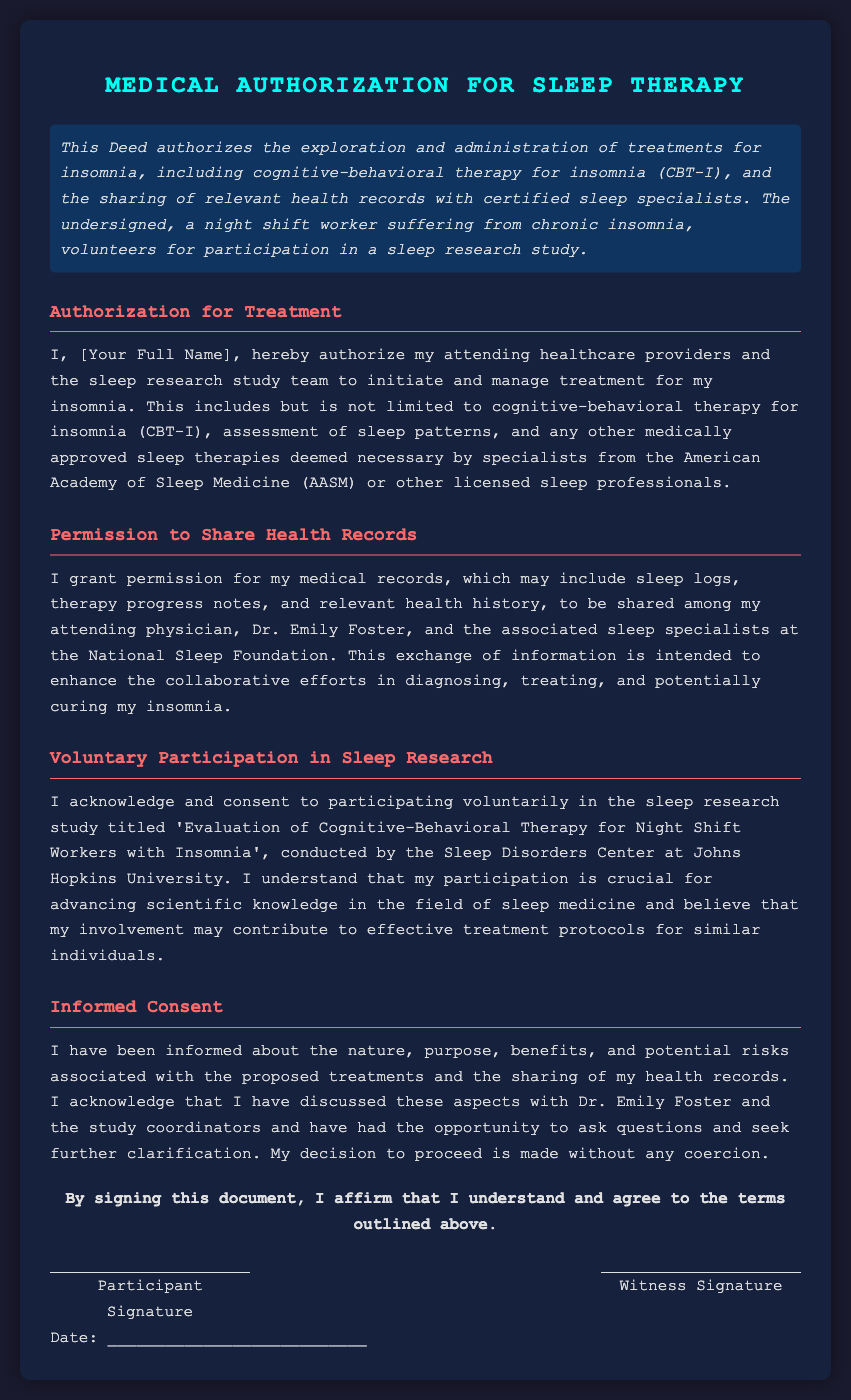What is the title of the document? The title is clearly stated at the top of the document, which indicates its purpose.
Answer: Medical Authorization for Sleep Therapy Who is the attending physician mentioned in the document? The physician's name is specifically written in the section that discusses sharing health records.
Answer: Dr. Emily Foster What type of therapy is primarily mentioned for treating insomnia? The document outlines the treatment method specified under the authorization for treatment section.
Answer: cognitive-behavioral therapy for insomnia (CBT-I) Which institution conducts the sleep research study? The name of the institution is indicated in the section about voluntary participation in sleep research.
Answer: Johns Hopkins University What is the main purpose of sharing medical records as per the document? The purpose is articulated clearly in the section concerning permission to share health records.
Answer: Enhance the collaborative efforts Is participating in the sleep research study mandatory? The document indicates the nature of participation regarding the research study.
Answer: Voluntary What information is granted for sharing concerning medical records? The type of information relevant to health records is detailed in the permission to share section.
Answer: sleep logs, therapy progress notes, and relevant health history What is the implication of signing the document? The final section outlines the affirmation that the participant agrees to the terms.
Answer: Affirm understanding and agreement to the terms 